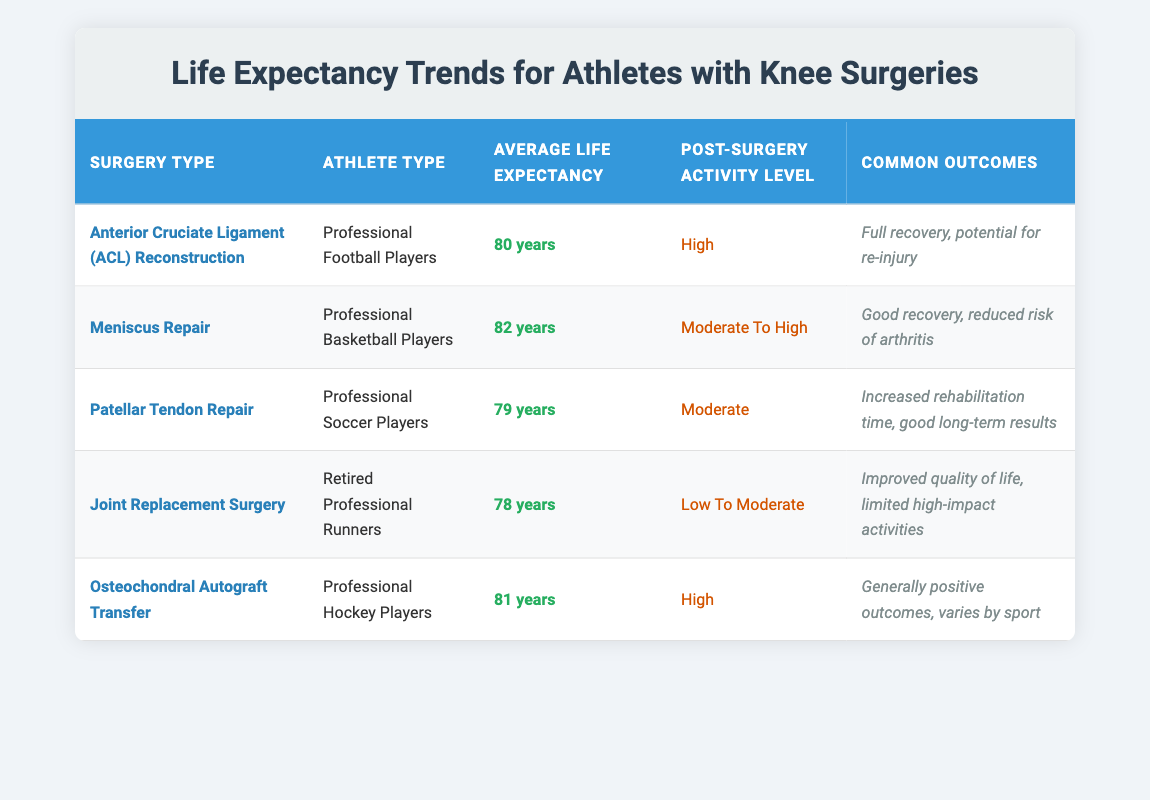What is the average life expectancy for Professional Basketball Players after Meniscus Repair? According to the table, the average life expectancy for Professional Basketball Players after Meniscus Repair is listed as 82 years.
Answer: 82 years Which surgery type has the lowest average life expectancy among the athletes listed? The table shows that Joint Replacement Surgery has the lowest average life expectancy at 78 years compared to the other surgeries listed.
Answer: Joint Replacement Surgery Is the post-surgery activity level for Professional Football Players high? The table indicates that the post-surgery activity level for athletes who underwent ACL Reconstruction is categorized as high. Therefore, the statement is true.
Answer: Yes What is the difference in average life expectancy between Professional Soccer Players and Professional Hockey Players? The average life expectancy for Professional Soccer Players is 79 years and for Professional Hockey Players is 81 years. The difference is 81 - 79 = 2 years.
Answer: 2 years Do retired professional runners have a higher average life expectancy than professional soccer players? The table shows that retired professional runners have an average life expectancy of 78 years while professional soccer players have an average life expectancy of 79 years. Therefore, the statement is false.
Answer: No What is the average life expectancy of athletes who undergo Anterior Cruciate Ligament (ACL) Reconstruction and Osteochondral Autograft Transfer combined? The average life expectancy for ACL Reconstruction is 80 years, and for Osteochondral Autograft Transfer, it is 81 years. To find the average: (80 + 81) / 2 = 80.5 years.
Answer: 80.5 years Which athlete type has the highest average life expectancy based on the surgeries listed? The table shows that Professional Basketball Players have the highest average life expectancy at 82 years among all athlete types mentioned.
Answer: Professional Basketball Players What are the common outcomes associated with Patellar Tendon Repair? The table states that the common outcomes for Patellar Tendon Repair include increased rehabilitation time and good long-term results.
Answer: Increased rehabilitation time, good long-term results What is the post-surgery activity level for professional football players? Based on the table, the post-surgery activity level for Professional Football Players after ACL Reconstruction is classified as high.
Answer: High 